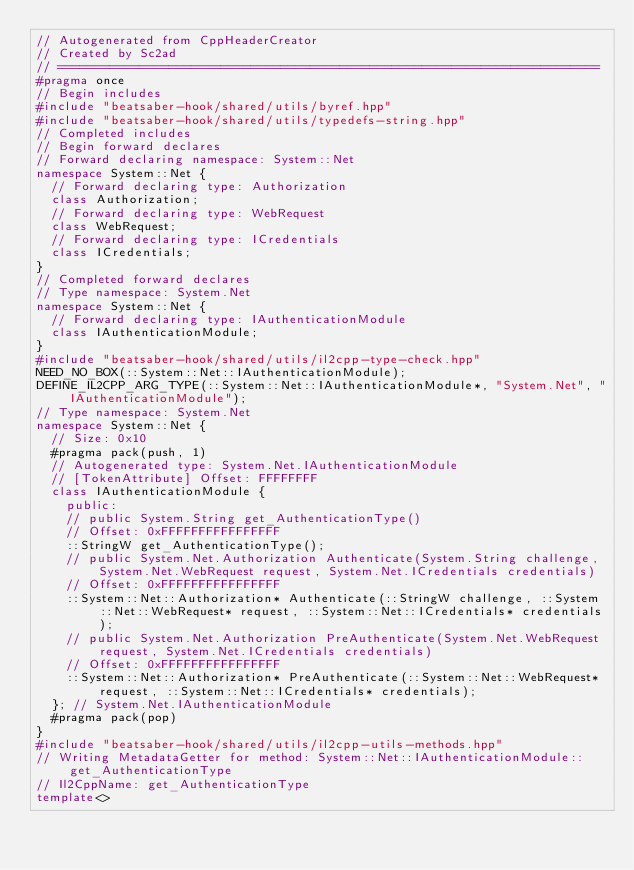Convert code to text. <code><loc_0><loc_0><loc_500><loc_500><_C++_>// Autogenerated from CppHeaderCreator
// Created by Sc2ad
// =========================================================================
#pragma once
// Begin includes
#include "beatsaber-hook/shared/utils/byref.hpp"
#include "beatsaber-hook/shared/utils/typedefs-string.hpp"
// Completed includes
// Begin forward declares
// Forward declaring namespace: System::Net
namespace System::Net {
  // Forward declaring type: Authorization
  class Authorization;
  // Forward declaring type: WebRequest
  class WebRequest;
  // Forward declaring type: ICredentials
  class ICredentials;
}
// Completed forward declares
// Type namespace: System.Net
namespace System::Net {
  // Forward declaring type: IAuthenticationModule
  class IAuthenticationModule;
}
#include "beatsaber-hook/shared/utils/il2cpp-type-check.hpp"
NEED_NO_BOX(::System::Net::IAuthenticationModule);
DEFINE_IL2CPP_ARG_TYPE(::System::Net::IAuthenticationModule*, "System.Net", "IAuthenticationModule");
// Type namespace: System.Net
namespace System::Net {
  // Size: 0x10
  #pragma pack(push, 1)
  // Autogenerated type: System.Net.IAuthenticationModule
  // [TokenAttribute] Offset: FFFFFFFF
  class IAuthenticationModule {
    public:
    // public System.String get_AuthenticationType()
    // Offset: 0xFFFFFFFFFFFFFFFF
    ::StringW get_AuthenticationType();
    // public System.Net.Authorization Authenticate(System.String challenge, System.Net.WebRequest request, System.Net.ICredentials credentials)
    // Offset: 0xFFFFFFFFFFFFFFFF
    ::System::Net::Authorization* Authenticate(::StringW challenge, ::System::Net::WebRequest* request, ::System::Net::ICredentials* credentials);
    // public System.Net.Authorization PreAuthenticate(System.Net.WebRequest request, System.Net.ICredentials credentials)
    // Offset: 0xFFFFFFFFFFFFFFFF
    ::System::Net::Authorization* PreAuthenticate(::System::Net::WebRequest* request, ::System::Net::ICredentials* credentials);
  }; // System.Net.IAuthenticationModule
  #pragma pack(pop)
}
#include "beatsaber-hook/shared/utils/il2cpp-utils-methods.hpp"
// Writing MetadataGetter for method: System::Net::IAuthenticationModule::get_AuthenticationType
// Il2CppName: get_AuthenticationType
template<></code> 